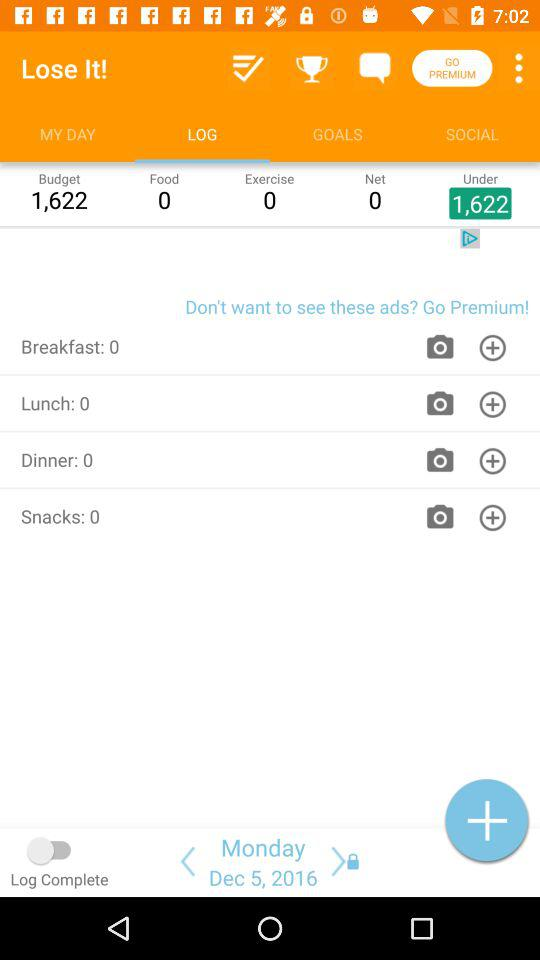How many calories have you eaten today?
Answer the question using a single word or phrase. 0 